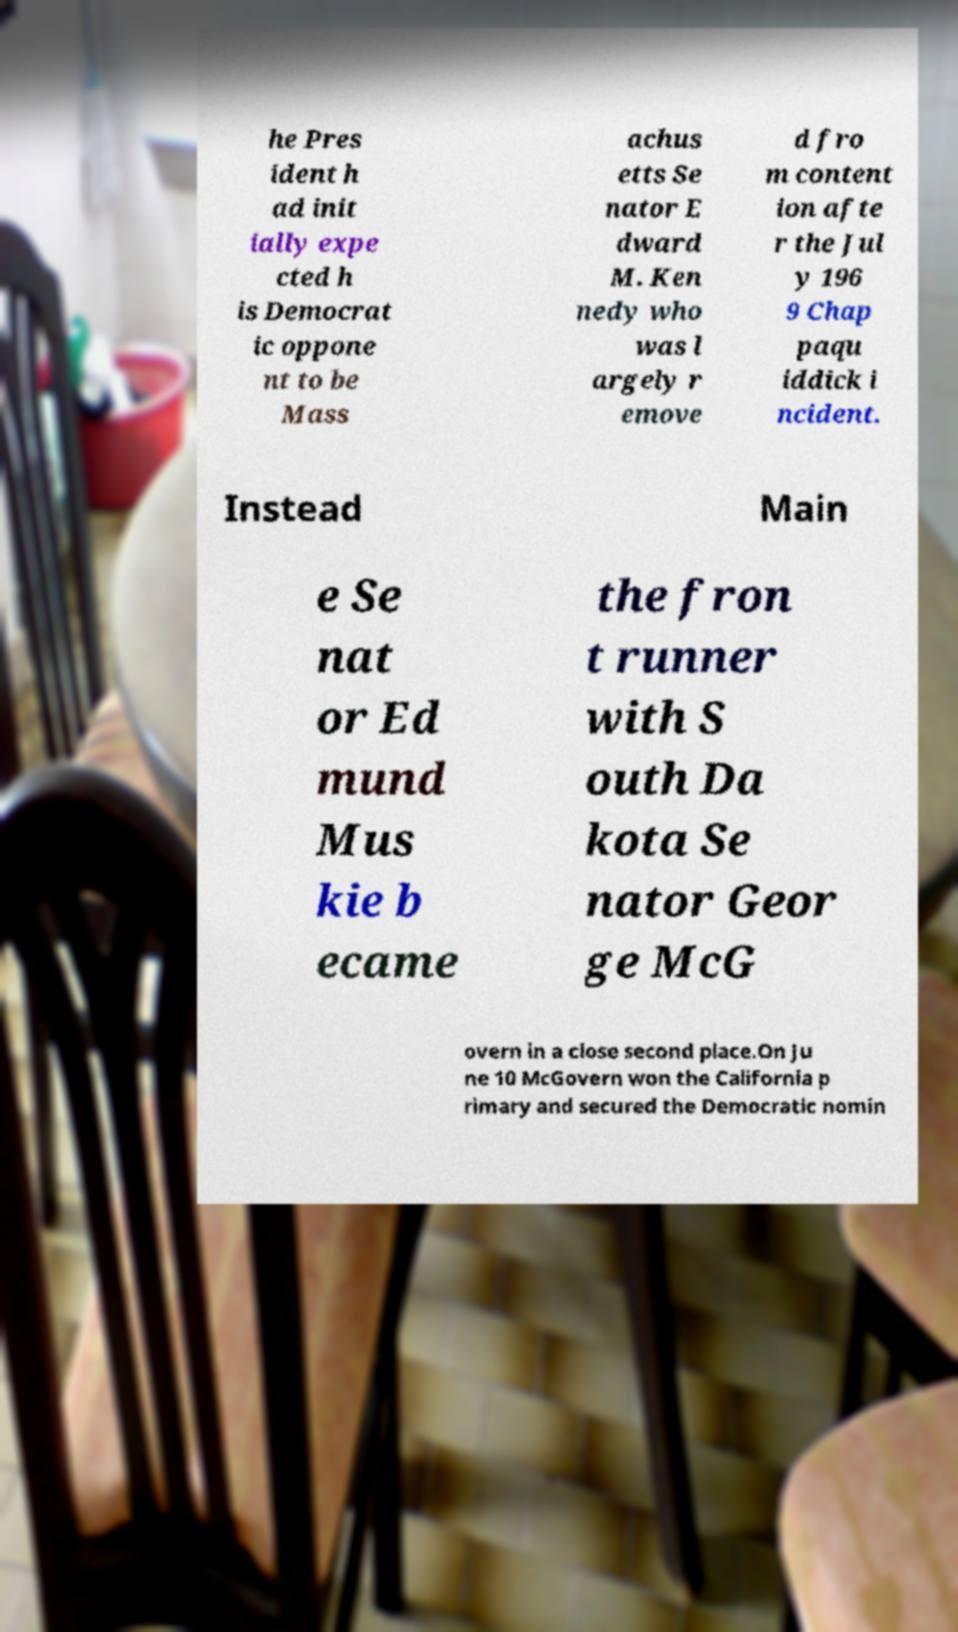For documentation purposes, I need the text within this image transcribed. Could you provide that? he Pres ident h ad init ially expe cted h is Democrat ic oppone nt to be Mass achus etts Se nator E dward M. Ken nedy who was l argely r emove d fro m content ion afte r the Jul y 196 9 Chap paqu iddick i ncident. Instead Main e Se nat or Ed mund Mus kie b ecame the fron t runner with S outh Da kota Se nator Geor ge McG overn in a close second place.On Ju ne 10 McGovern won the California p rimary and secured the Democratic nomin 